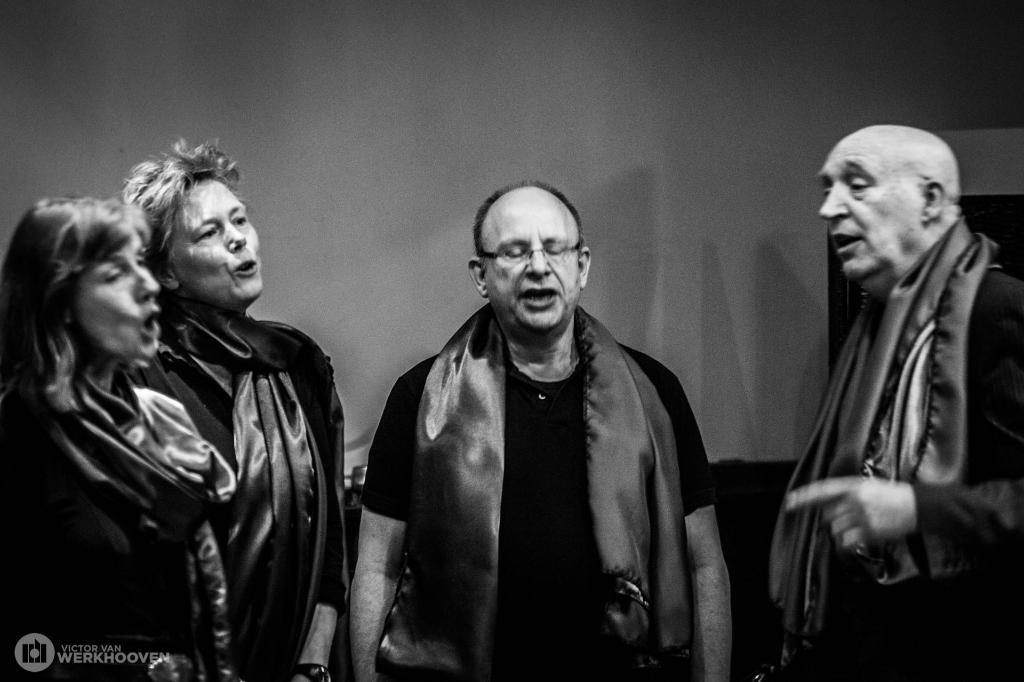What can be seen in the image? There are people standing in the image. What is the background of the image? There is a wall visible in the image. How is the image presented? The image is in black and white. What type of quiver can be seen on the wall in the image? There is no quiver present in the image; it only features people standing and a wall. Can you hear the guitar playing in the image? There is no guitar present in the image, so it cannot be heard. 